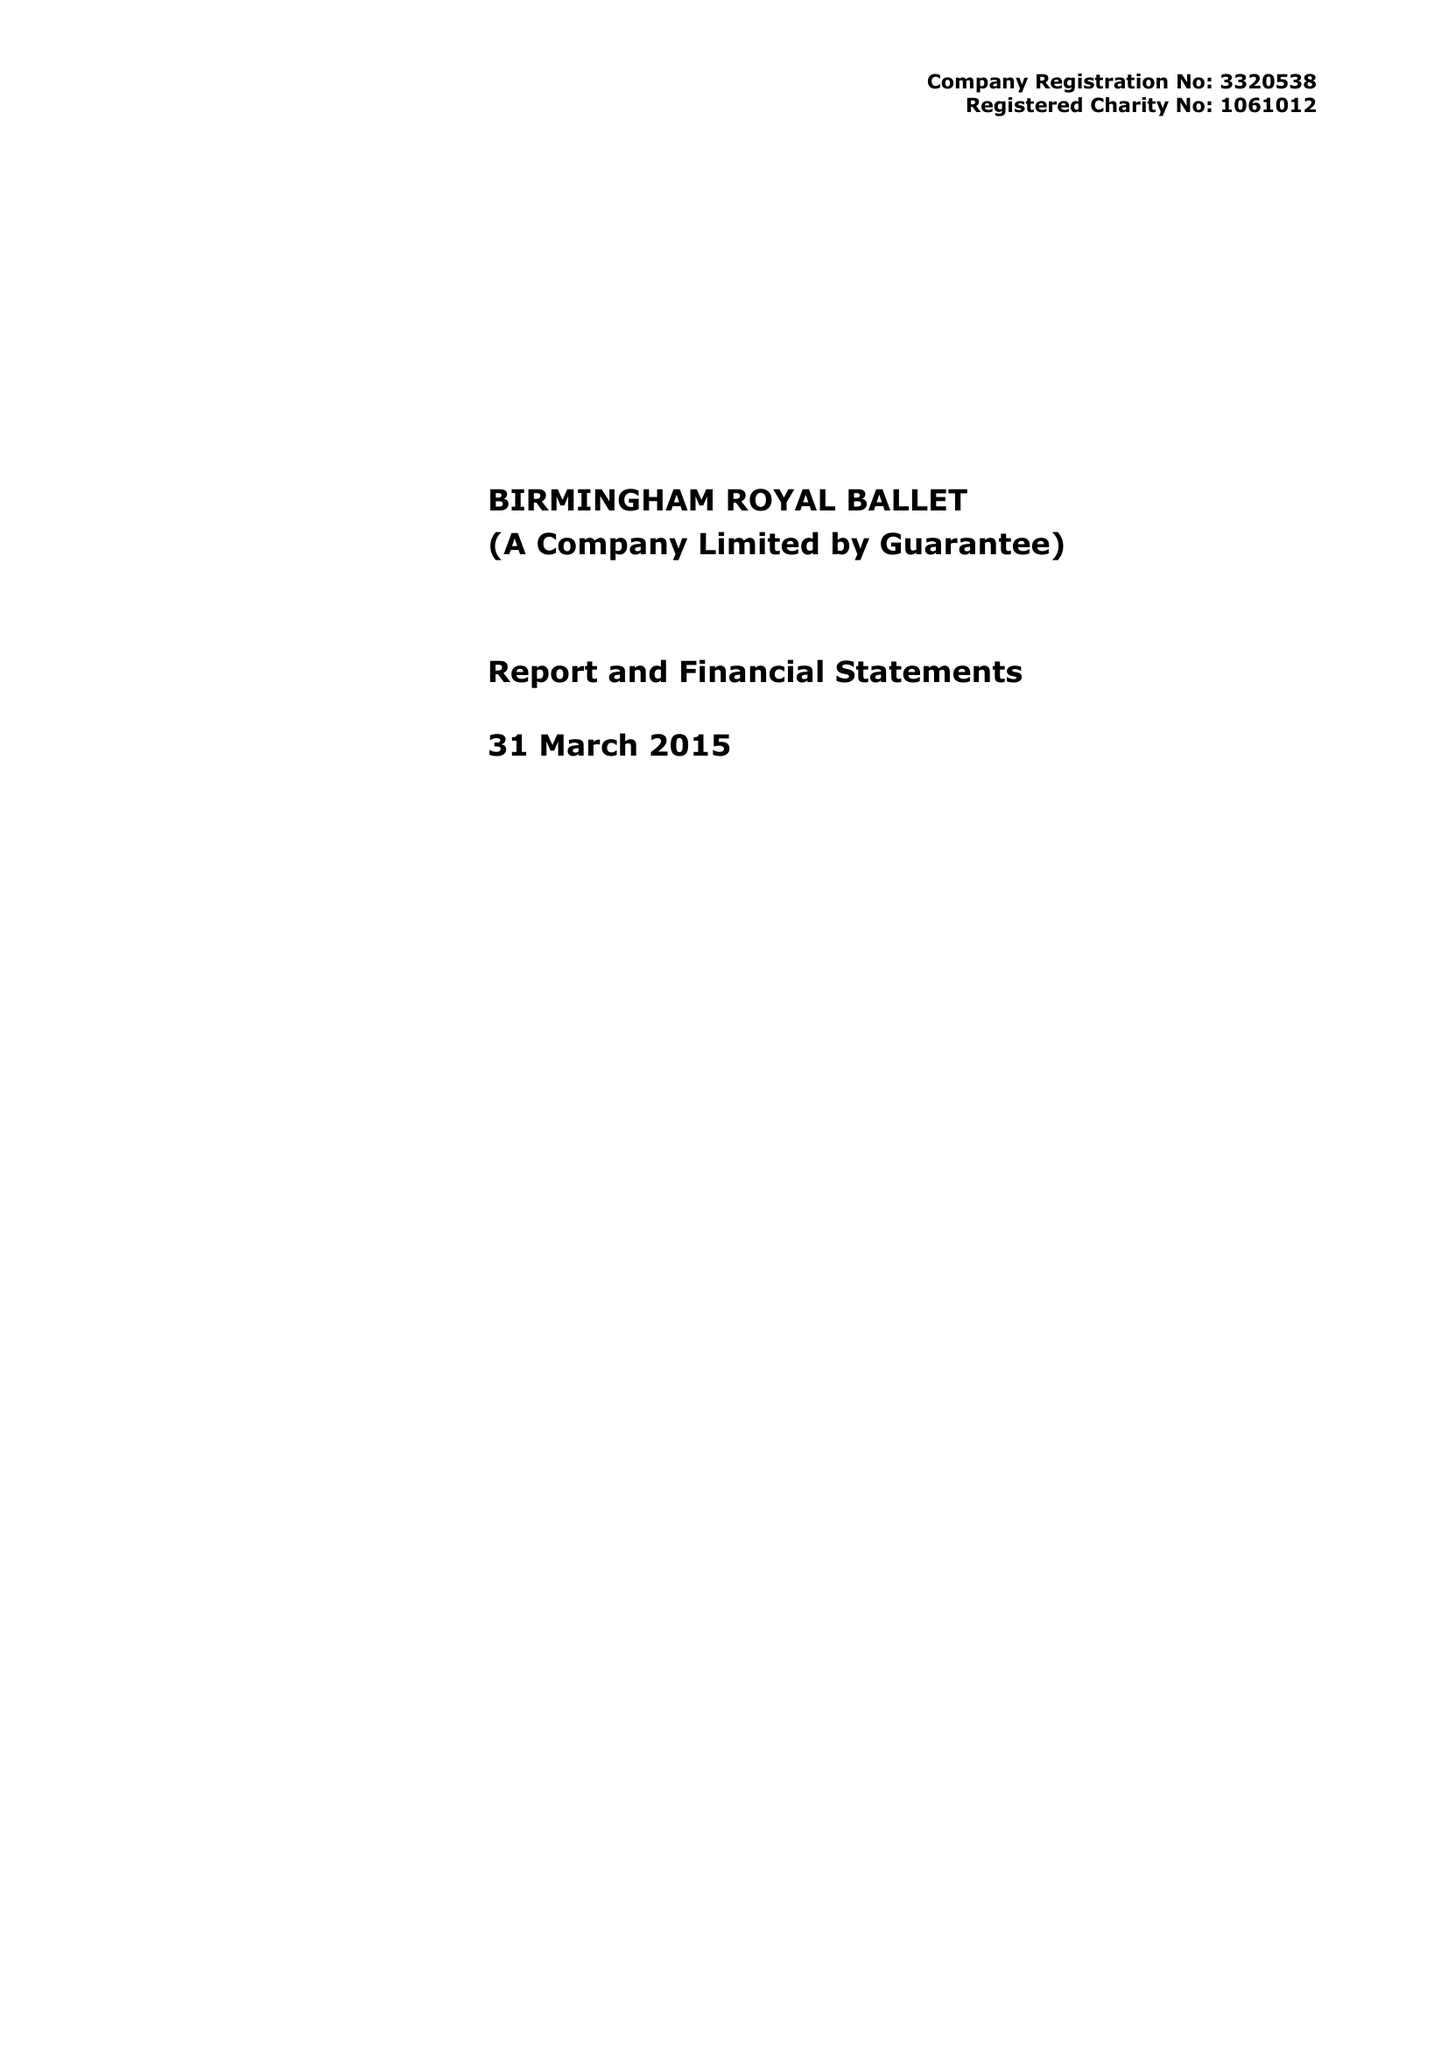What is the value for the charity_number?
Answer the question using a single word or phrase. 1061012 